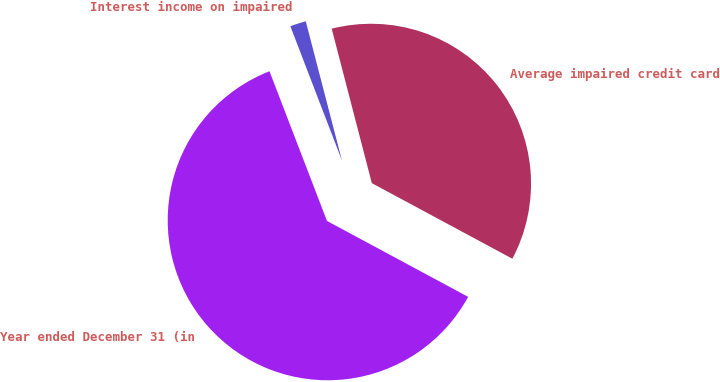Convert chart. <chart><loc_0><loc_0><loc_500><loc_500><pie_chart><fcel>Year ended December 31 (in<fcel>Average impaired credit card<fcel>Interest income on impaired<nl><fcel>61.31%<fcel>36.9%<fcel>1.79%<nl></chart> 